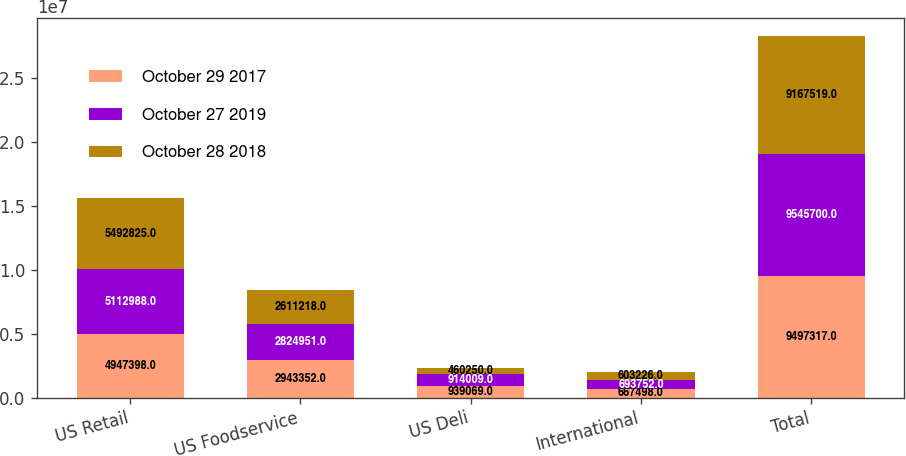Convert chart. <chart><loc_0><loc_0><loc_500><loc_500><stacked_bar_chart><ecel><fcel>US Retail<fcel>US Foodservice<fcel>US Deli<fcel>International<fcel>Total<nl><fcel>October 29 2017<fcel>4.9474e+06<fcel>2.94335e+06<fcel>939069<fcel>667498<fcel>9.49732e+06<nl><fcel>October 27 2019<fcel>5.11299e+06<fcel>2.82495e+06<fcel>914009<fcel>693752<fcel>9.5457e+06<nl><fcel>October 28 2018<fcel>5.49282e+06<fcel>2.61122e+06<fcel>460250<fcel>603226<fcel>9.16752e+06<nl></chart> 